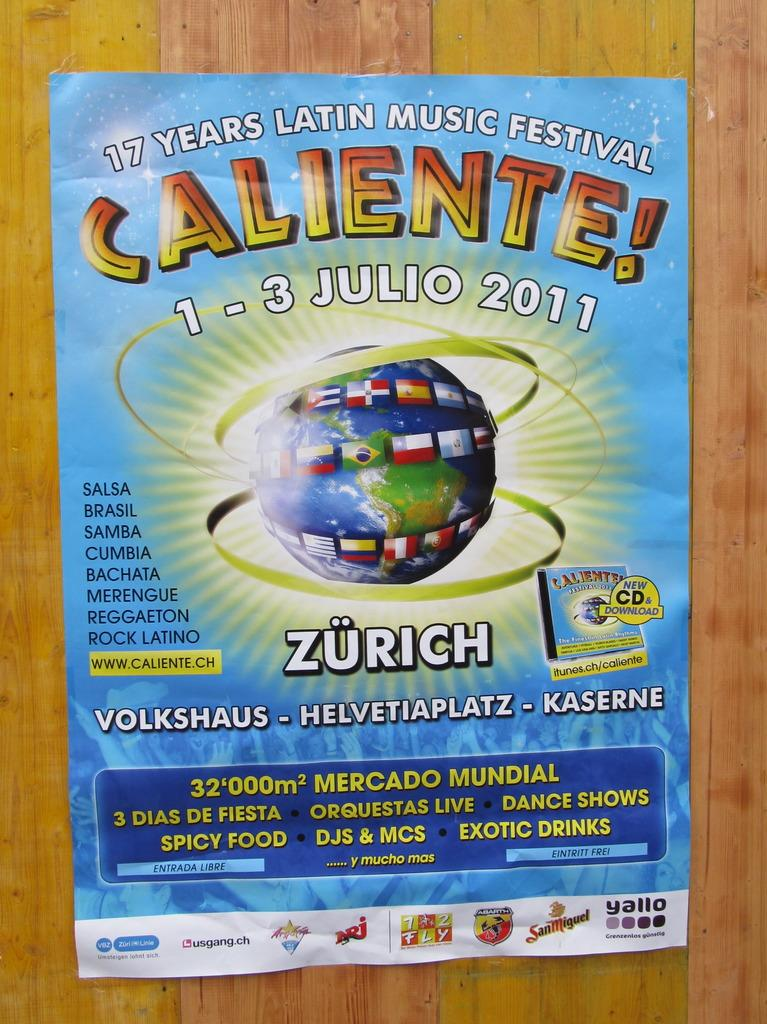Provide a one-sentence caption for the provided image. 1-3 Julio is the date of the Caliente festival. 